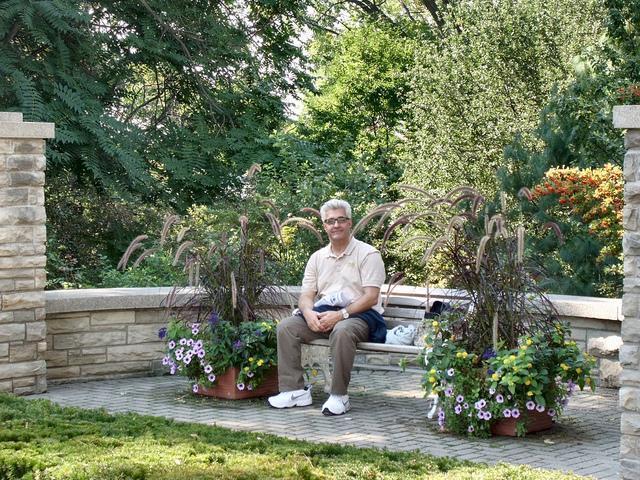How many planters are there?
Give a very brief answer. 2. How many people are in the picture?
Give a very brief answer. 1. How many people are visible?
Give a very brief answer. 1. How many potted plants are in the picture?
Give a very brief answer. 3. How many of the tables have a television on them?
Give a very brief answer. 0. 